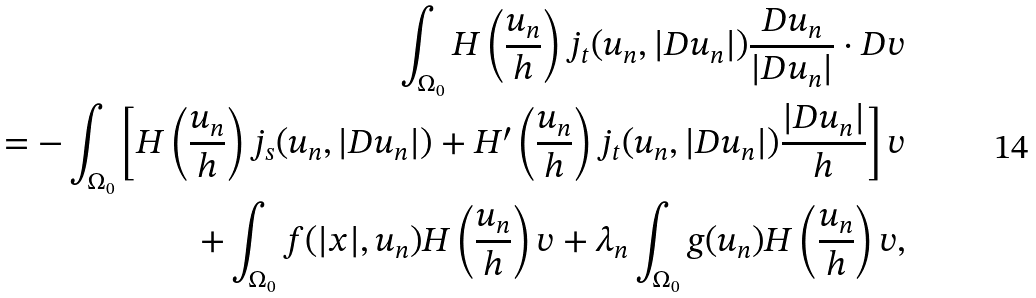Convert formula to latex. <formula><loc_0><loc_0><loc_500><loc_500>\int _ { \Omega _ { 0 } } H \left ( \frac { u _ { n } } { h } \right ) j _ { t } ( u _ { n } , | D u _ { n } | ) \frac { D u _ { n } } { | D u _ { n } | } \cdot D v \\ = - \int _ { \Omega _ { 0 } } \left [ H \left ( \frac { u _ { n } } { h } \right ) j _ { s } ( u _ { n } , | D u _ { n } | ) + H ^ { \prime } \left ( \frac { u _ { n } } { h } \right ) j _ { t } ( u _ { n } , | D u _ { n } | ) \frac { | D u _ { n } | } { h } \right ] v \\ + \int _ { \Omega _ { 0 } } f ( | x | , u _ { n } ) H \left ( \frac { u _ { n } } { h } \right ) v + \lambda _ { n } \int _ { \Omega _ { 0 } } g ( u _ { n } ) H \left ( \frac { u _ { n } } { h } \right ) v ,</formula> 